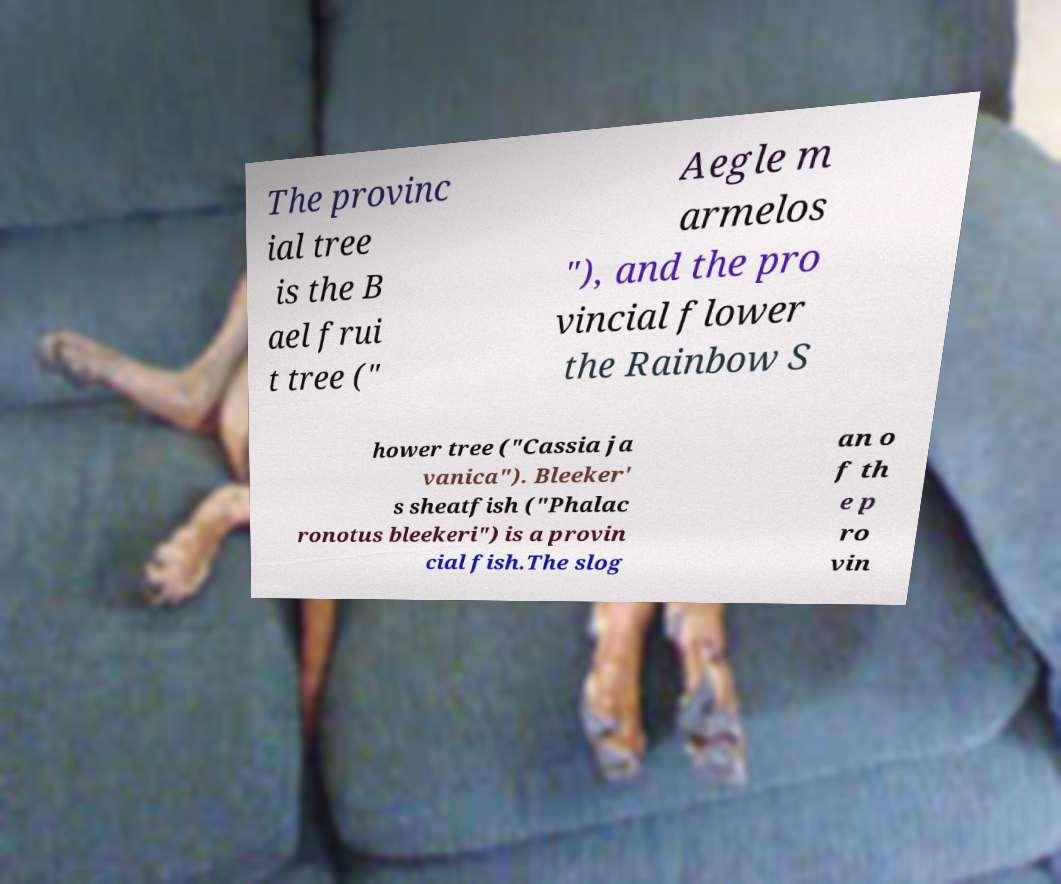I need the written content from this picture converted into text. Can you do that? The provinc ial tree is the B ael frui t tree (" Aegle m armelos "), and the pro vincial flower the Rainbow S hower tree ("Cassia ja vanica"). Bleeker' s sheatfish ("Phalac ronotus bleekeri") is a provin cial fish.The slog an o f th e p ro vin 